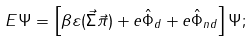Convert formula to latex. <formula><loc_0><loc_0><loc_500><loc_500>E \Psi = \left [ \beta \varepsilon ( \vec { \Sigma } \vec { \pi } ) + e \hat { \Phi } _ { d } + e \hat { \Phi } _ { n d } \right ] \Psi ;</formula> 